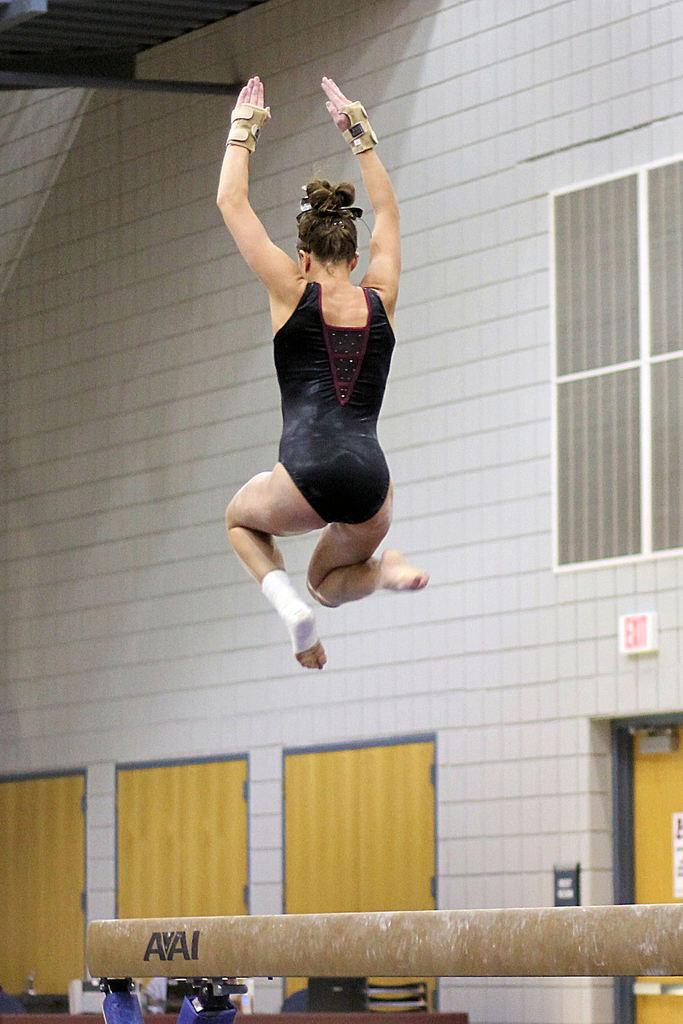Who is present in the image? There is a woman in the image. What is the woman wearing? The woman is wearing a dress and gloves. What can be seen in the background of the image? There is a pole, a group of doors, windows, and a metal railing in the background of the image. What type of silk is draped over the shelf in the image? There is no shelf or silk present in the image. 